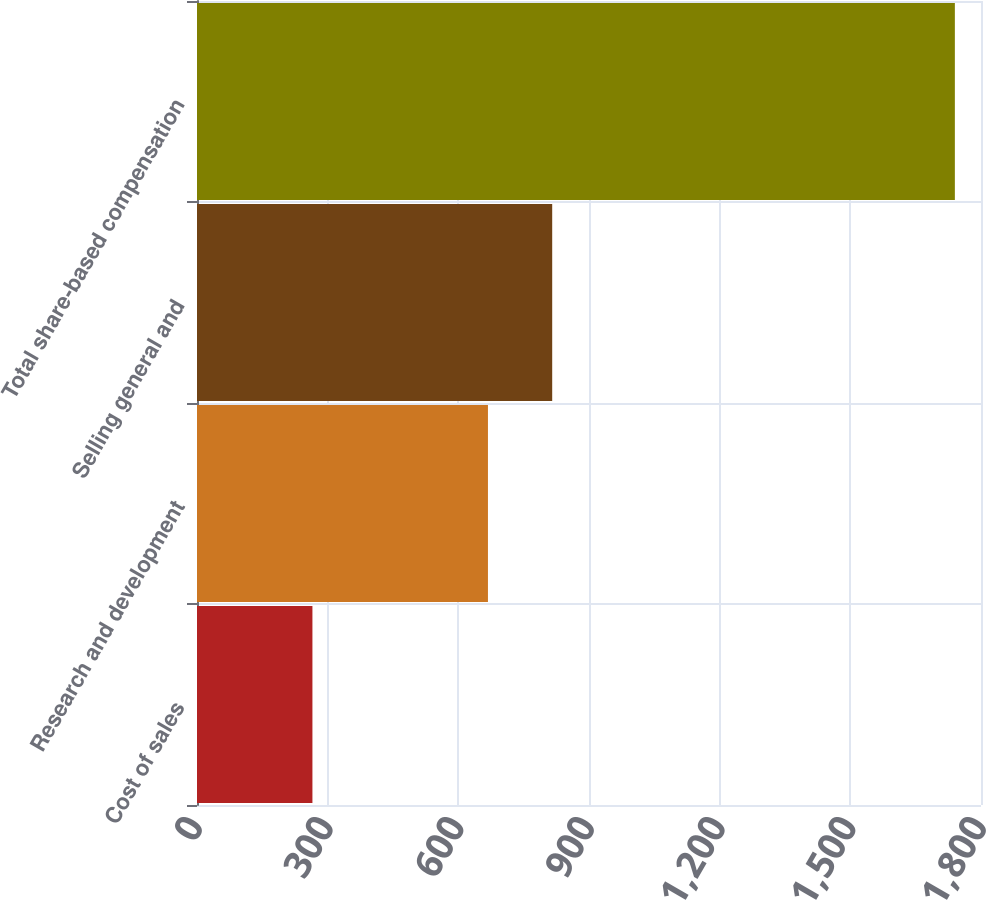Convert chart. <chart><loc_0><loc_0><loc_500><loc_500><bar_chart><fcel>Cost of sales<fcel>Research and development<fcel>Selling general and<fcel>Total share-based compensation<nl><fcel>265<fcel>668<fcel>815.5<fcel>1740<nl></chart> 